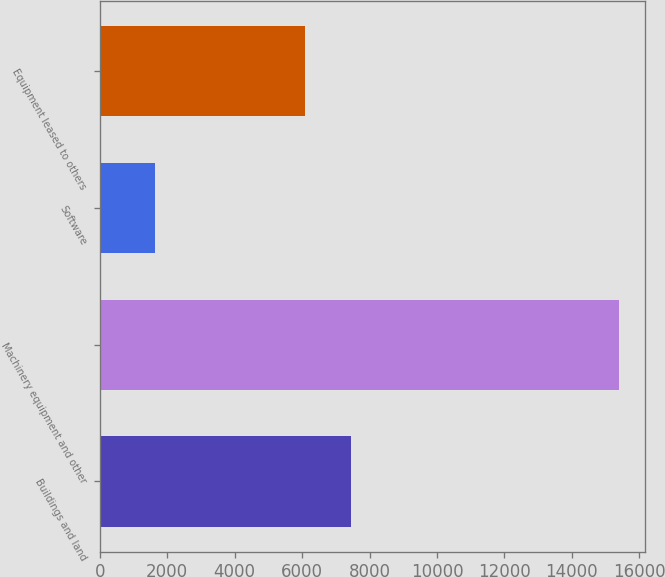Convert chart. <chart><loc_0><loc_0><loc_500><loc_500><bar_chart><fcel>Buildings and land<fcel>Machinery equipment and other<fcel>Software<fcel>Equipment leased to others<nl><fcel>7461.1<fcel>15392<fcel>1641<fcel>6086<nl></chart> 